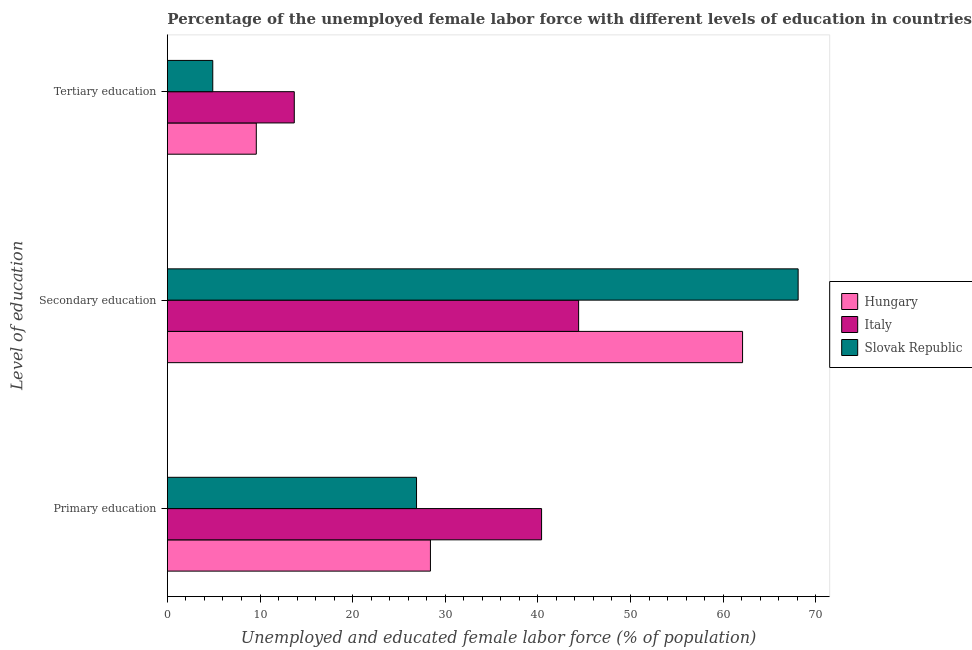How many groups of bars are there?
Offer a terse response. 3. How many bars are there on the 1st tick from the top?
Offer a terse response. 3. How many bars are there on the 2nd tick from the bottom?
Provide a succinct answer. 3. What is the label of the 2nd group of bars from the top?
Ensure brevity in your answer.  Secondary education. What is the percentage of female labor force who received tertiary education in Slovak Republic?
Make the answer very short. 4.9. Across all countries, what is the maximum percentage of female labor force who received primary education?
Provide a succinct answer. 40.4. Across all countries, what is the minimum percentage of female labor force who received tertiary education?
Make the answer very short. 4.9. In which country was the percentage of female labor force who received tertiary education maximum?
Offer a very short reply. Italy. In which country was the percentage of female labor force who received primary education minimum?
Provide a short and direct response. Slovak Republic. What is the total percentage of female labor force who received primary education in the graph?
Make the answer very short. 95.7. What is the difference between the percentage of female labor force who received primary education in Hungary and that in Slovak Republic?
Provide a short and direct response. 1.5. What is the difference between the percentage of female labor force who received primary education in Slovak Republic and the percentage of female labor force who received tertiary education in Hungary?
Provide a short and direct response. 17.3. What is the average percentage of female labor force who received secondary education per country?
Offer a very short reply. 58.2. What is the difference between the percentage of female labor force who received tertiary education and percentage of female labor force who received secondary education in Italy?
Your answer should be compact. -30.7. What is the ratio of the percentage of female labor force who received tertiary education in Hungary to that in Slovak Republic?
Provide a succinct answer. 1.96. Is the percentage of female labor force who received tertiary education in Slovak Republic less than that in Hungary?
Your answer should be compact. Yes. What is the difference between the highest and the second highest percentage of female labor force who received secondary education?
Make the answer very short. 6. What is the difference between the highest and the lowest percentage of female labor force who received primary education?
Your answer should be compact. 13.5. In how many countries, is the percentage of female labor force who received secondary education greater than the average percentage of female labor force who received secondary education taken over all countries?
Your answer should be very brief. 2. What does the 2nd bar from the top in Secondary education represents?
Ensure brevity in your answer.  Italy. What does the 1st bar from the bottom in Primary education represents?
Offer a very short reply. Hungary. Is it the case that in every country, the sum of the percentage of female labor force who received primary education and percentage of female labor force who received secondary education is greater than the percentage of female labor force who received tertiary education?
Provide a succinct answer. Yes. What is the difference between two consecutive major ticks on the X-axis?
Provide a short and direct response. 10. Are the values on the major ticks of X-axis written in scientific E-notation?
Make the answer very short. No. Does the graph contain any zero values?
Make the answer very short. No. Does the graph contain grids?
Keep it short and to the point. No. Where does the legend appear in the graph?
Offer a terse response. Center right. What is the title of the graph?
Make the answer very short. Percentage of the unemployed female labor force with different levels of education in countries. What is the label or title of the X-axis?
Your answer should be very brief. Unemployed and educated female labor force (% of population). What is the label or title of the Y-axis?
Provide a short and direct response. Level of education. What is the Unemployed and educated female labor force (% of population) in Hungary in Primary education?
Provide a succinct answer. 28.4. What is the Unemployed and educated female labor force (% of population) of Italy in Primary education?
Provide a short and direct response. 40.4. What is the Unemployed and educated female labor force (% of population) of Slovak Republic in Primary education?
Keep it short and to the point. 26.9. What is the Unemployed and educated female labor force (% of population) of Hungary in Secondary education?
Your answer should be very brief. 62.1. What is the Unemployed and educated female labor force (% of population) of Italy in Secondary education?
Provide a succinct answer. 44.4. What is the Unemployed and educated female labor force (% of population) of Slovak Republic in Secondary education?
Ensure brevity in your answer.  68.1. What is the Unemployed and educated female labor force (% of population) of Hungary in Tertiary education?
Provide a short and direct response. 9.6. What is the Unemployed and educated female labor force (% of population) in Italy in Tertiary education?
Offer a very short reply. 13.7. What is the Unemployed and educated female labor force (% of population) of Slovak Republic in Tertiary education?
Offer a very short reply. 4.9. Across all Level of education, what is the maximum Unemployed and educated female labor force (% of population) in Hungary?
Offer a terse response. 62.1. Across all Level of education, what is the maximum Unemployed and educated female labor force (% of population) in Italy?
Your answer should be very brief. 44.4. Across all Level of education, what is the maximum Unemployed and educated female labor force (% of population) of Slovak Republic?
Ensure brevity in your answer.  68.1. Across all Level of education, what is the minimum Unemployed and educated female labor force (% of population) in Hungary?
Offer a terse response. 9.6. Across all Level of education, what is the minimum Unemployed and educated female labor force (% of population) in Italy?
Give a very brief answer. 13.7. Across all Level of education, what is the minimum Unemployed and educated female labor force (% of population) of Slovak Republic?
Your answer should be compact. 4.9. What is the total Unemployed and educated female labor force (% of population) of Hungary in the graph?
Ensure brevity in your answer.  100.1. What is the total Unemployed and educated female labor force (% of population) in Italy in the graph?
Offer a very short reply. 98.5. What is the total Unemployed and educated female labor force (% of population) in Slovak Republic in the graph?
Keep it short and to the point. 99.9. What is the difference between the Unemployed and educated female labor force (% of population) of Hungary in Primary education and that in Secondary education?
Make the answer very short. -33.7. What is the difference between the Unemployed and educated female labor force (% of population) in Italy in Primary education and that in Secondary education?
Your answer should be compact. -4. What is the difference between the Unemployed and educated female labor force (% of population) in Slovak Republic in Primary education and that in Secondary education?
Your response must be concise. -41.2. What is the difference between the Unemployed and educated female labor force (% of population) of Hungary in Primary education and that in Tertiary education?
Ensure brevity in your answer.  18.8. What is the difference between the Unemployed and educated female labor force (% of population) of Italy in Primary education and that in Tertiary education?
Give a very brief answer. 26.7. What is the difference between the Unemployed and educated female labor force (% of population) of Slovak Republic in Primary education and that in Tertiary education?
Your answer should be compact. 22. What is the difference between the Unemployed and educated female labor force (% of population) in Hungary in Secondary education and that in Tertiary education?
Make the answer very short. 52.5. What is the difference between the Unemployed and educated female labor force (% of population) in Italy in Secondary education and that in Tertiary education?
Your response must be concise. 30.7. What is the difference between the Unemployed and educated female labor force (% of population) in Slovak Republic in Secondary education and that in Tertiary education?
Offer a very short reply. 63.2. What is the difference between the Unemployed and educated female labor force (% of population) of Hungary in Primary education and the Unemployed and educated female labor force (% of population) of Italy in Secondary education?
Offer a terse response. -16. What is the difference between the Unemployed and educated female labor force (% of population) of Hungary in Primary education and the Unemployed and educated female labor force (% of population) of Slovak Republic in Secondary education?
Your response must be concise. -39.7. What is the difference between the Unemployed and educated female labor force (% of population) of Italy in Primary education and the Unemployed and educated female labor force (% of population) of Slovak Republic in Secondary education?
Your response must be concise. -27.7. What is the difference between the Unemployed and educated female labor force (% of population) of Hungary in Primary education and the Unemployed and educated female labor force (% of population) of Slovak Republic in Tertiary education?
Your answer should be compact. 23.5. What is the difference between the Unemployed and educated female labor force (% of population) in Italy in Primary education and the Unemployed and educated female labor force (% of population) in Slovak Republic in Tertiary education?
Make the answer very short. 35.5. What is the difference between the Unemployed and educated female labor force (% of population) in Hungary in Secondary education and the Unemployed and educated female labor force (% of population) in Italy in Tertiary education?
Make the answer very short. 48.4. What is the difference between the Unemployed and educated female labor force (% of population) in Hungary in Secondary education and the Unemployed and educated female labor force (% of population) in Slovak Republic in Tertiary education?
Your response must be concise. 57.2. What is the difference between the Unemployed and educated female labor force (% of population) of Italy in Secondary education and the Unemployed and educated female labor force (% of population) of Slovak Republic in Tertiary education?
Make the answer very short. 39.5. What is the average Unemployed and educated female labor force (% of population) of Hungary per Level of education?
Ensure brevity in your answer.  33.37. What is the average Unemployed and educated female labor force (% of population) in Italy per Level of education?
Your answer should be very brief. 32.83. What is the average Unemployed and educated female labor force (% of population) in Slovak Republic per Level of education?
Give a very brief answer. 33.3. What is the difference between the Unemployed and educated female labor force (% of population) of Hungary and Unemployed and educated female labor force (% of population) of Italy in Primary education?
Provide a succinct answer. -12. What is the difference between the Unemployed and educated female labor force (% of population) of Hungary and Unemployed and educated female labor force (% of population) of Slovak Republic in Primary education?
Ensure brevity in your answer.  1.5. What is the difference between the Unemployed and educated female labor force (% of population) of Italy and Unemployed and educated female labor force (% of population) of Slovak Republic in Secondary education?
Offer a very short reply. -23.7. What is the difference between the Unemployed and educated female labor force (% of population) of Hungary and Unemployed and educated female labor force (% of population) of Slovak Republic in Tertiary education?
Provide a short and direct response. 4.7. What is the ratio of the Unemployed and educated female labor force (% of population) in Hungary in Primary education to that in Secondary education?
Your response must be concise. 0.46. What is the ratio of the Unemployed and educated female labor force (% of population) of Italy in Primary education to that in Secondary education?
Your answer should be very brief. 0.91. What is the ratio of the Unemployed and educated female labor force (% of population) in Slovak Republic in Primary education to that in Secondary education?
Make the answer very short. 0.4. What is the ratio of the Unemployed and educated female labor force (% of population) in Hungary in Primary education to that in Tertiary education?
Make the answer very short. 2.96. What is the ratio of the Unemployed and educated female labor force (% of population) in Italy in Primary education to that in Tertiary education?
Keep it short and to the point. 2.95. What is the ratio of the Unemployed and educated female labor force (% of population) in Slovak Republic in Primary education to that in Tertiary education?
Your response must be concise. 5.49. What is the ratio of the Unemployed and educated female labor force (% of population) in Hungary in Secondary education to that in Tertiary education?
Your answer should be very brief. 6.47. What is the ratio of the Unemployed and educated female labor force (% of population) of Italy in Secondary education to that in Tertiary education?
Keep it short and to the point. 3.24. What is the ratio of the Unemployed and educated female labor force (% of population) of Slovak Republic in Secondary education to that in Tertiary education?
Give a very brief answer. 13.9. What is the difference between the highest and the second highest Unemployed and educated female labor force (% of population) of Hungary?
Provide a succinct answer. 33.7. What is the difference between the highest and the second highest Unemployed and educated female labor force (% of population) in Italy?
Offer a very short reply. 4. What is the difference between the highest and the second highest Unemployed and educated female labor force (% of population) of Slovak Republic?
Your response must be concise. 41.2. What is the difference between the highest and the lowest Unemployed and educated female labor force (% of population) in Hungary?
Your answer should be very brief. 52.5. What is the difference between the highest and the lowest Unemployed and educated female labor force (% of population) of Italy?
Make the answer very short. 30.7. What is the difference between the highest and the lowest Unemployed and educated female labor force (% of population) in Slovak Republic?
Your response must be concise. 63.2. 